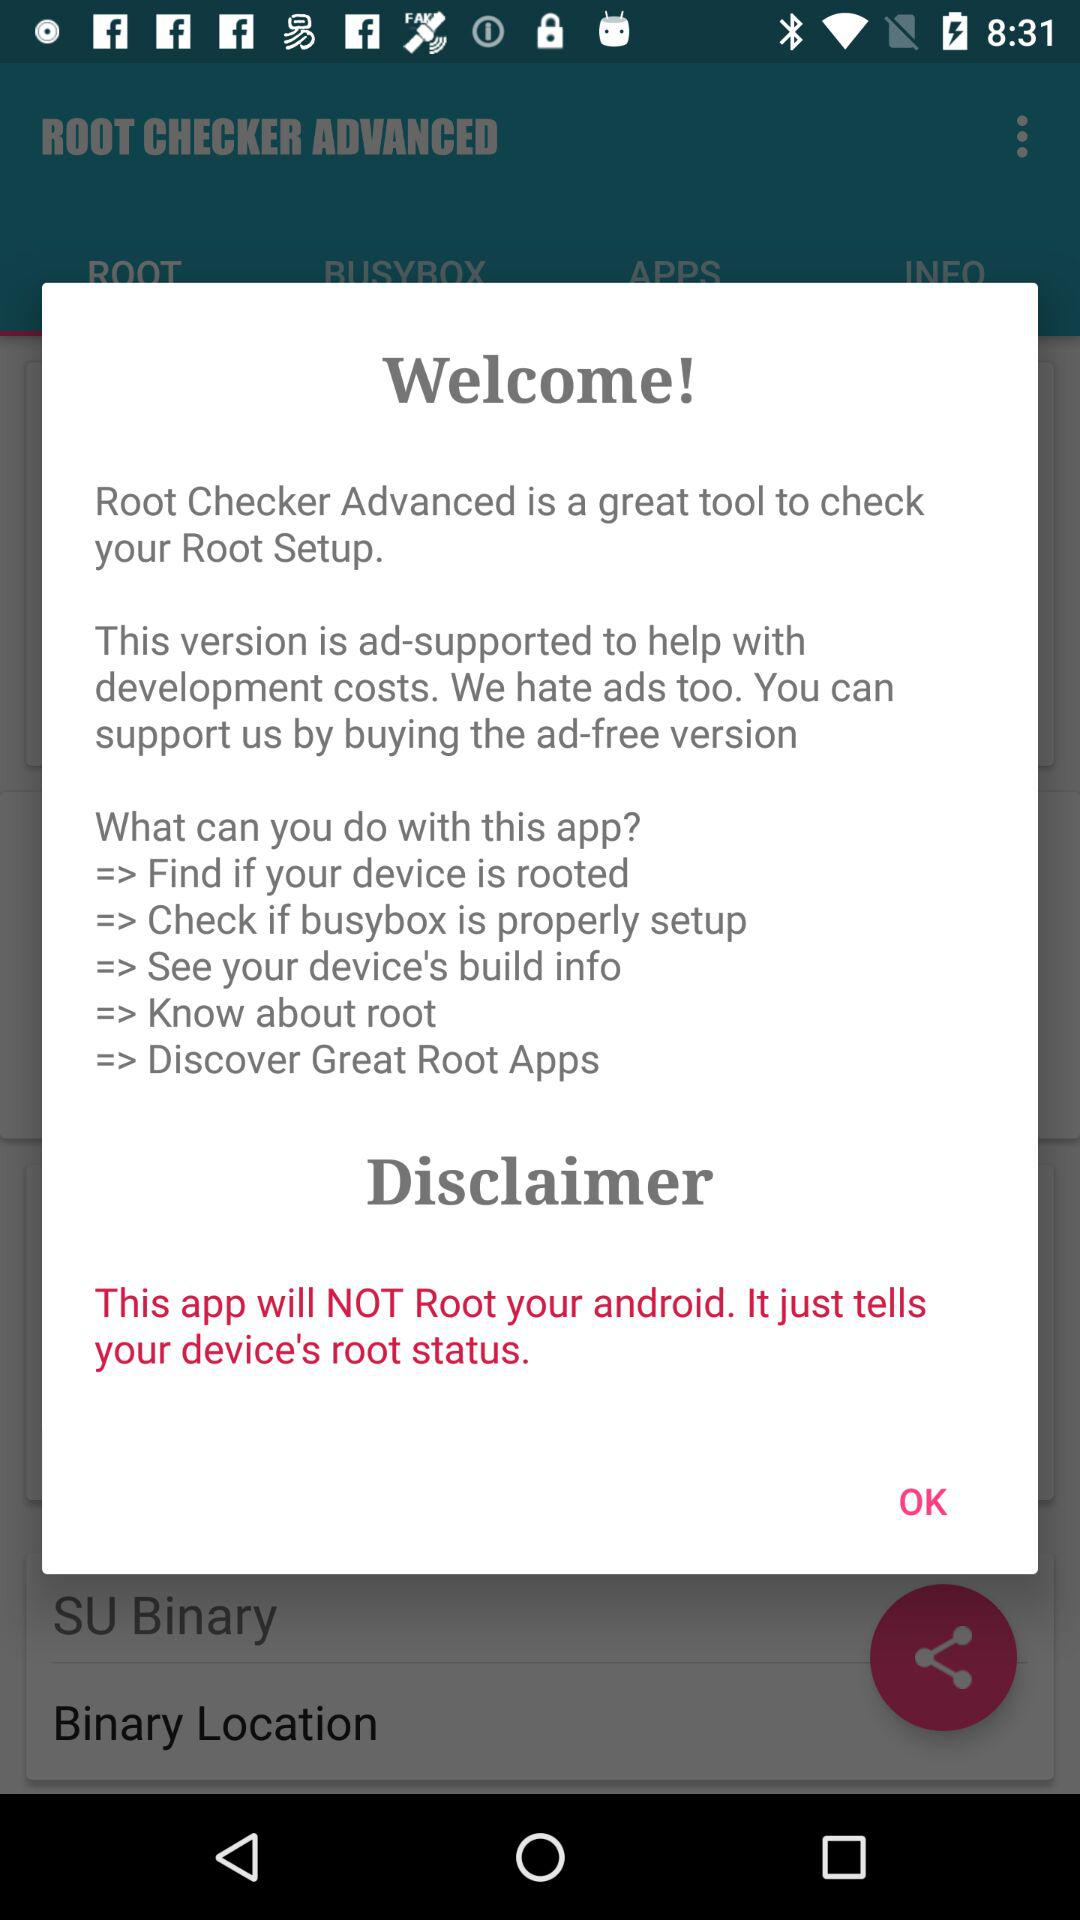What is the application name? The application name is "ROOT CHECKER ADVANCED". 